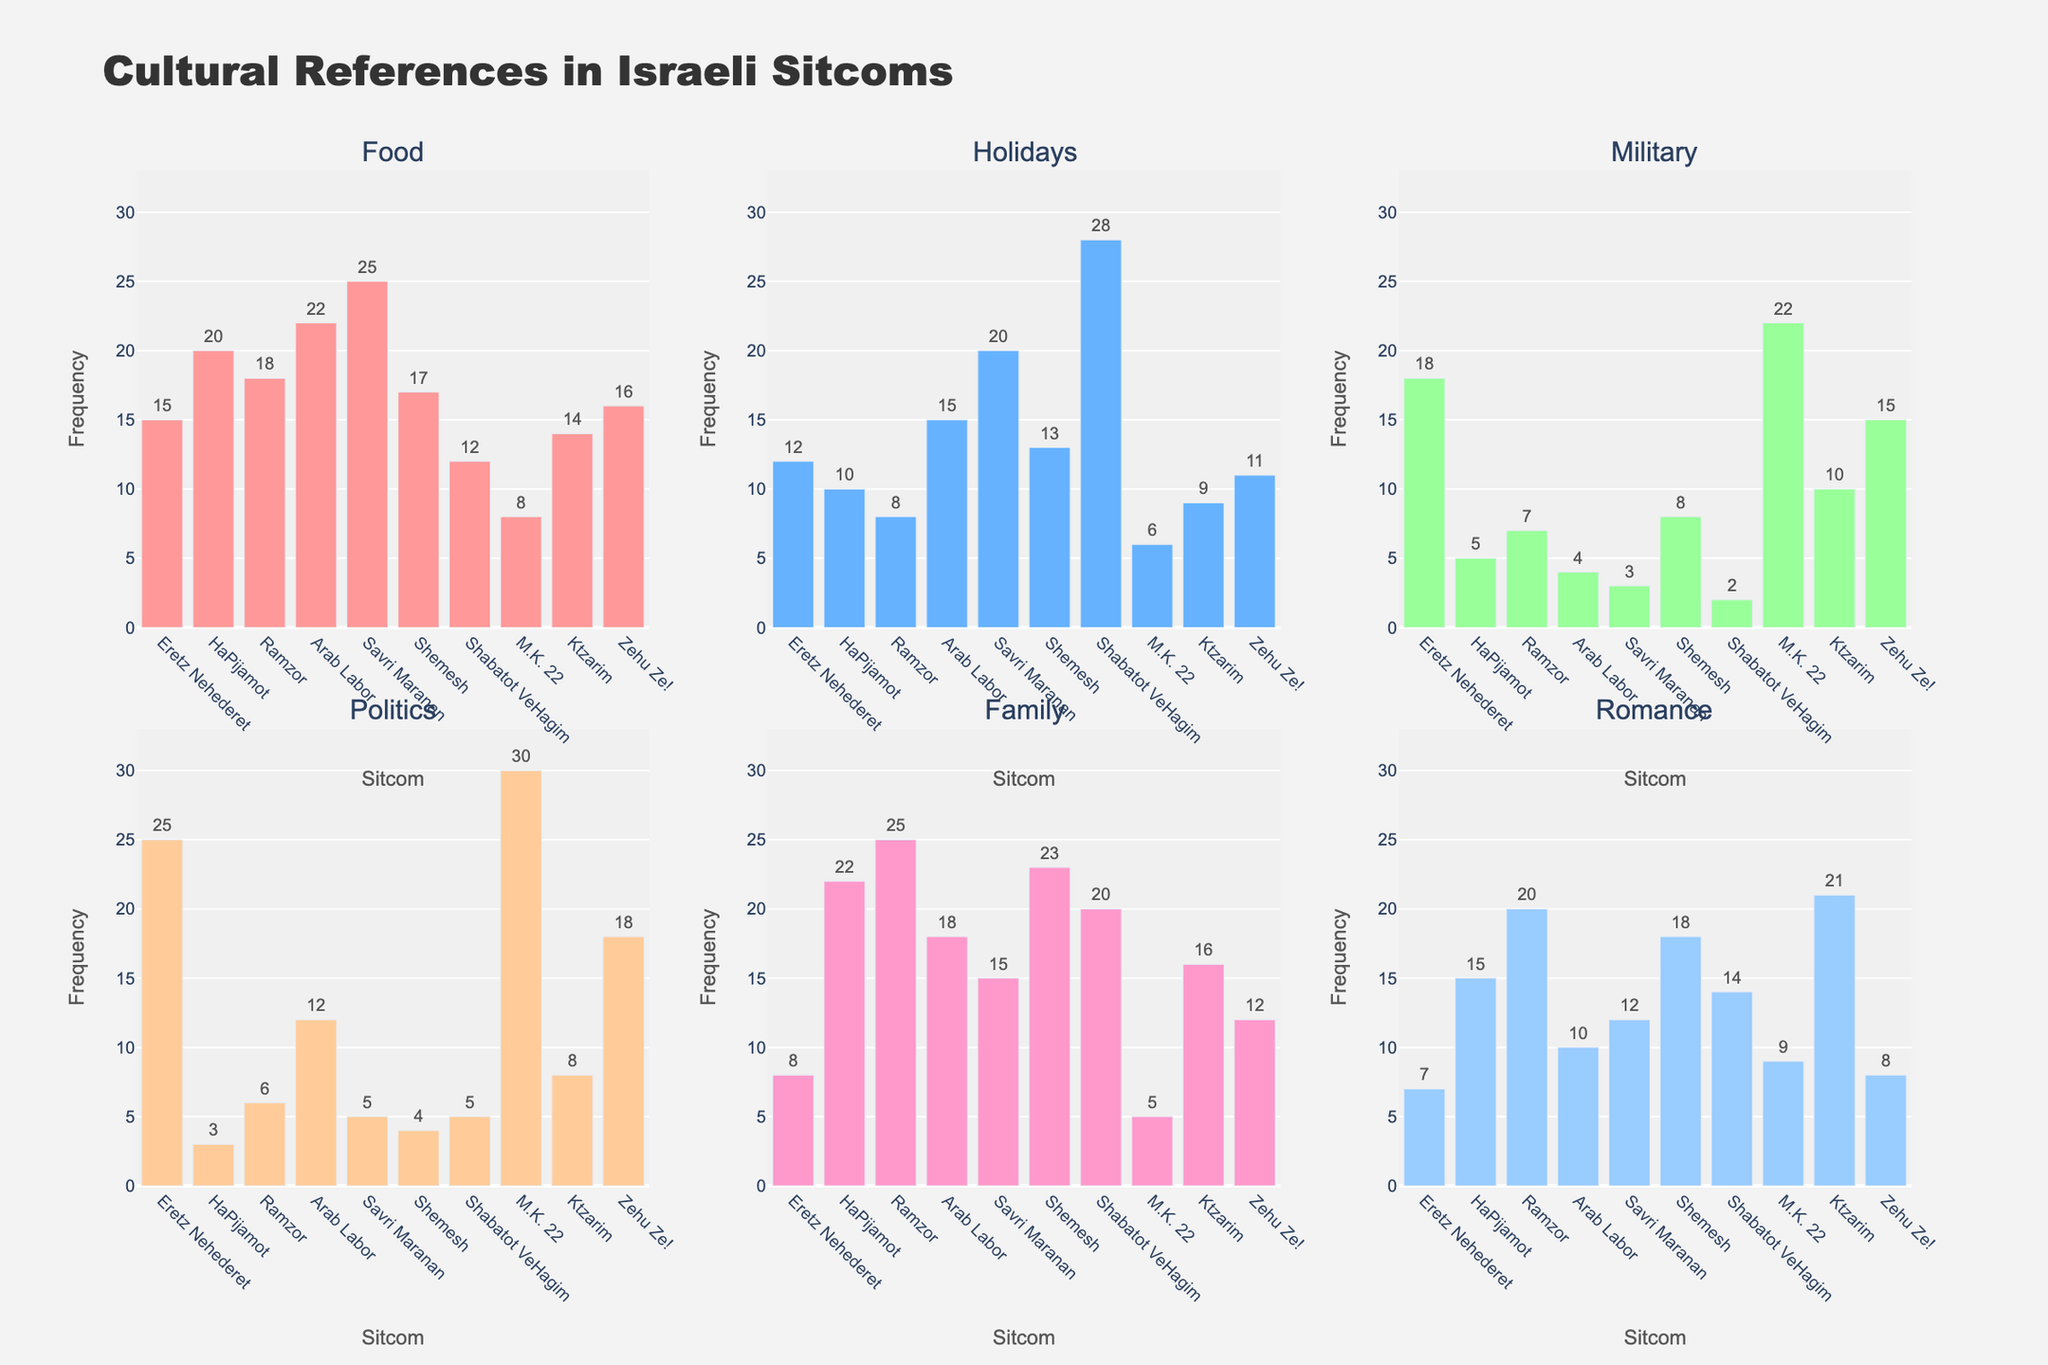What's the title of the figure? The title of the figure is found at the top center of the figure, and it provides a summary of what the figure is about.
Answer: Allocation of Educational Resources Across School Districts Which school district has the highest percentage allocation for Instruction? By examining each pie chart, identify the slice labeled "Instruction" in each district. Compare the percentages to find the highest value.
Answer: Sunnyside Elementary What is the combined percentage of Administration and Operations for Riverside Unified? Locate the Riverside Unified pie chart, find the slices for Administration and Operations, and add their percentages together (14% + 16%).
Answer: 30% How does the percentage allocated to Support Services in Pine Valley District compare to the same in Highland Secondary? Identify the Support Services slices in both Pine Valley and Highland Secondary. Compare their percentages (10% in Pine Valley vs. 11% in Highland Secondary).
Answer: Pine Valley District has 1% less Which district has the most balanced allocation across all expenditure types? Look at the slices in each district's pie chart and identify the district where the slices are most uniform in size.
Answer: Highland Secondary What is the average percentage allocation for Extracurricular activities across all districts? Find the percentage for Extracurricular activities in each district, add them together (3% + 3% + 3% + 3% + 3% + 3% + 3% = 21%), then divide by the number of districts (21%/7).
Answer: 3% Is there any district where Instruction takes more than 60% of the total allocation? Check each district’s pie chart for the slice labeled "Instruction" and see if any percentage exceeds 60%.
Answer: Fairview School District, Sunnyside Elementary What's the difference in percentage allocation to Operations between Oakridge Public Schools and Meadowbrook Schools? Identify the percentage for Operations in both Oakridge Public Schools (17%) and Meadowbrook Schools (16%). Calculate the difference (17% - 16%).
Answer: 1% Which district allocates the least to Administration? Compare the Administration slices across all districts and find the lowest percentage.
Answer: Sunnyside Elementary What is the percentage allocation for Support Services in districts where the percentage for Operations is greater than 15%? Select districts where Operations > 15% (Riverside Unified, Oakridge Public Schools, Pine Valley District, Highland Secondary), then find the Support Services percentages in these districts (9% + 9% + 10% + 11%). Analyze these percentages.
Answer: 9%, 9%, 10%, 11% 